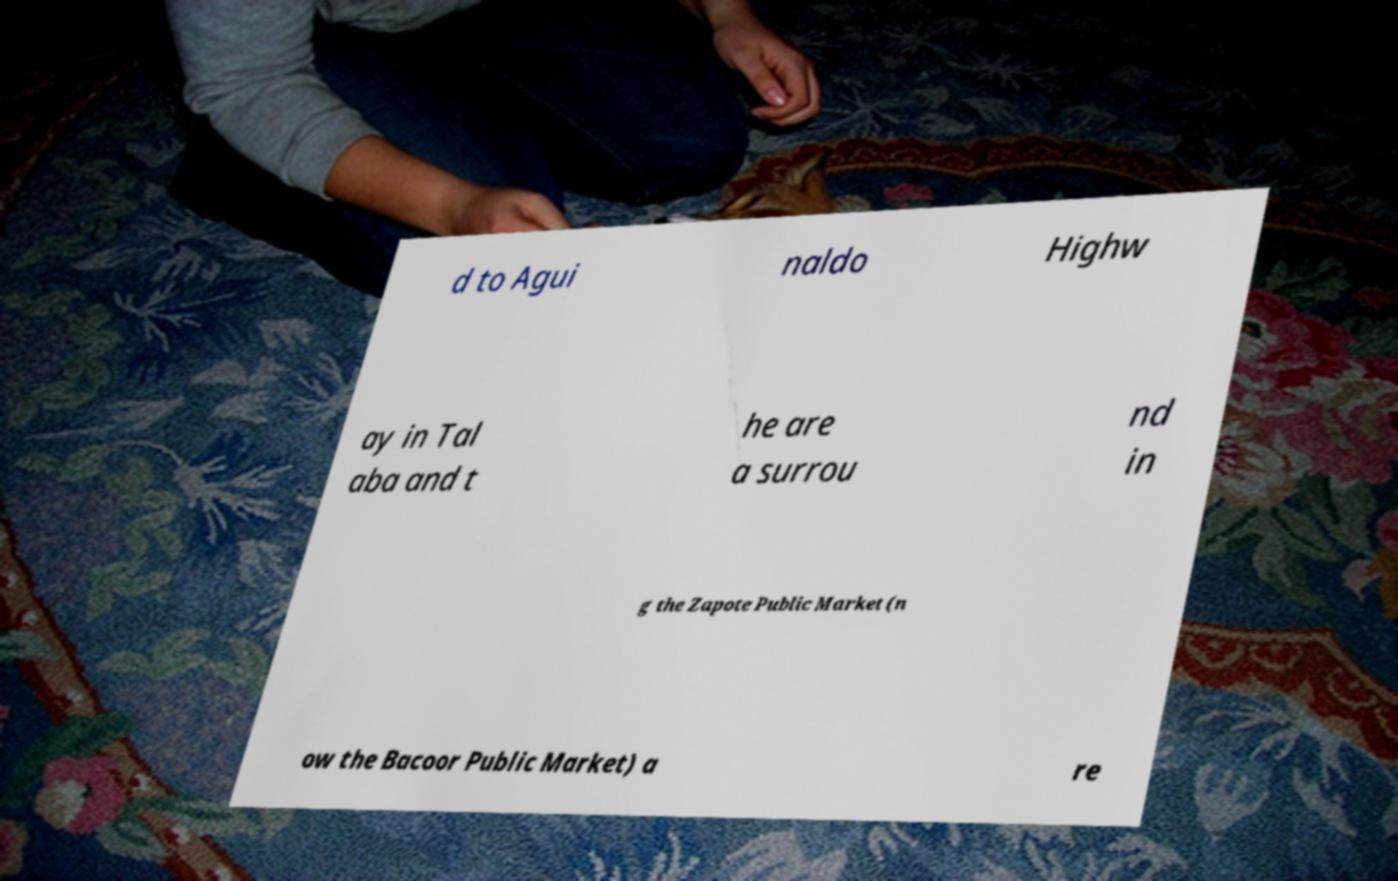Could you assist in decoding the text presented in this image and type it out clearly? d to Agui naldo Highw ay in Tal aba and t he are a surrou nd in g the Zapote Public Market (n ow the Bacoor Public Market) a re 